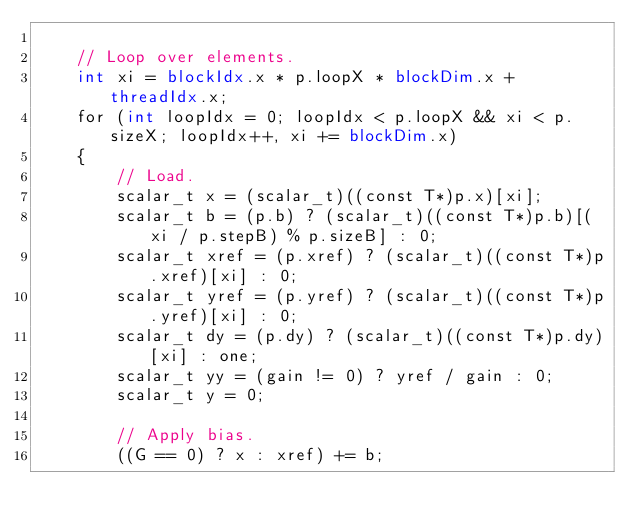<code> <loc_0><loc_0><loc_500><loc_500><_Cuda_>
    // Loop over elements.
    int xi = blockIdx.x * p.loopX * blockDim.x + threadIdx.x;
    for (int loopIdx = 0; loopIdx < p.loopX && xi < p.sizeX; loopIdx++, xi += blockDim.x)
    {
        // Load.
        scalar_t x = (scalar_t)((const T*)p.x)[xi];
        scalar_t b = (p.b) ? (scalar_t)((const T*)p.b)[(xi / p.stepB) % p.sizeB] : 0;
        scalar_t xref = (p.xref) ? (scalar_t)((const T*)p.xref)[xi] : 0;
        scalar_t yref = (p.yref) ? (scalar_t)((const T*)p.yref)[xi] : 0;
        scalar_t dy = (p.dy) ? (scalar_t)((const T*)p.dy)[xi] : one;
        scalar_t yy = (gain != 0) ? yref / gain : 0;
        scalar_t y = 0;

        // Apply bias.
        ((G == 0) ? x : xref) += b;
</code> 